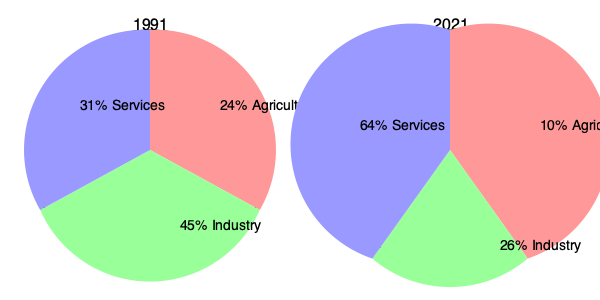Analyzing the pie charts representing Ukraine's economic sectors in 1991 and 2021, what significant change can be observed in the services sector, and how does this reflect the country's economic development over the past three decades? To answer this question, we need to analyze the changes in the services sector between 1991 and 2021:

1. Services sector in 1991: 31% of the economy
2. Services sector in 2021: 64% of the economy

The change in the services sector can be calculated as follows:

$$ \text{Change} = 64\% - 31\% = 33\% $$

This represents a significant increase of 33 percentage points in the services sector over 30 years.

This shift reflects Ukraine's economic development in several ways:

1. Transition from Soviet-era economy: The 1991 chart shows a more industrial and agricultural-focused economy, typical of the Soviet period.

2. Modernization: The growth in services indicates a move towards a more modern, post-industrial economy.

3. Tertiarization: This process, where the service sector becomes dominant, is common in developing and transitioning economies.

4. Decline in traditional sectors: The growth in services corresponds with significant decreases in both agriculture (from 24% to 10%) and industry (from 45% to 26%).

5. Economic restructuring: This shift suggests a major restructuring of the Ukrainian economy following independence, moving away from the centrally-planned Soviet model towards a market-oriented economy.

This substantial growth in the services sector reflects Ukraine's economic transition and development from a Soviet republic to an independent nation with a more diversified, service-oriented economy.
Answer: 33% increase in services sector, indicating economic modernization and transition from Soviet-era economy 